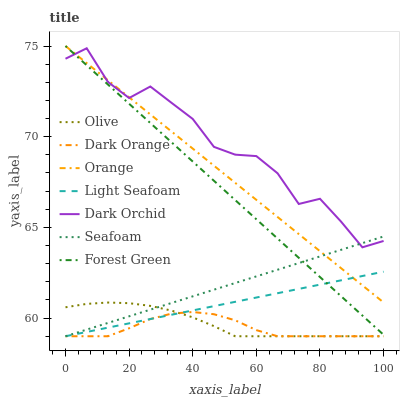Does Dark Orange have the minimum area under the curve?
Answer yes or no. Yes. Does Dark Orchid have the maximum area under the curve?
Answer yes or no. Yes. Does Seafoam have the minimum area under the curve?
Answer yes or no. No. Does Seafoam have the maximum area under the curve?
Answer yes or no. No. Is Orange the smoothest?
Answer yes or no. Yes. Is Dark Orchid the roughest?
Answer yes or no. Yes. Is Seafoam the smoothest?
Answer yes or no. No. Is Seafoam the roughest?
Answer yes or no. No. Does Dark Orange have the lowest value?
Answer yes or no. Yes. Does Dark Orchid have the lowest value?
Answer yes or no. No. Does Forest Green have the highest value?
Answer yes or no. Yes. Does Seafoam have the highest value?
Answer yes or no. No. Is Dark Orange less than Forest Green?
Answer yes or no. Yes. Is Dark Orchid greater than Light Seafoam?
Answer yes or no. Yes. Does Dark Orchid intersect Seafoam?
Answer yes or no. Yes. Is Dark Orchid less than Seafoam?
Answer yes or no. No. Is Dark Orchid greater than Seafoam?
Answer yes or no. No. Does Dark Orange intersect Forest Green?
Answer yes or no. No. 